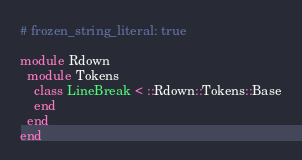Convert code to text. <code><loc_0><loc_0><loc_500><loc_500><_Ruby_># frozen_string_literal: true

module Rdown
  module Tokens
    class LineBreak < ::Rdown::Tokens::Base
    end
  end
end
</code> 